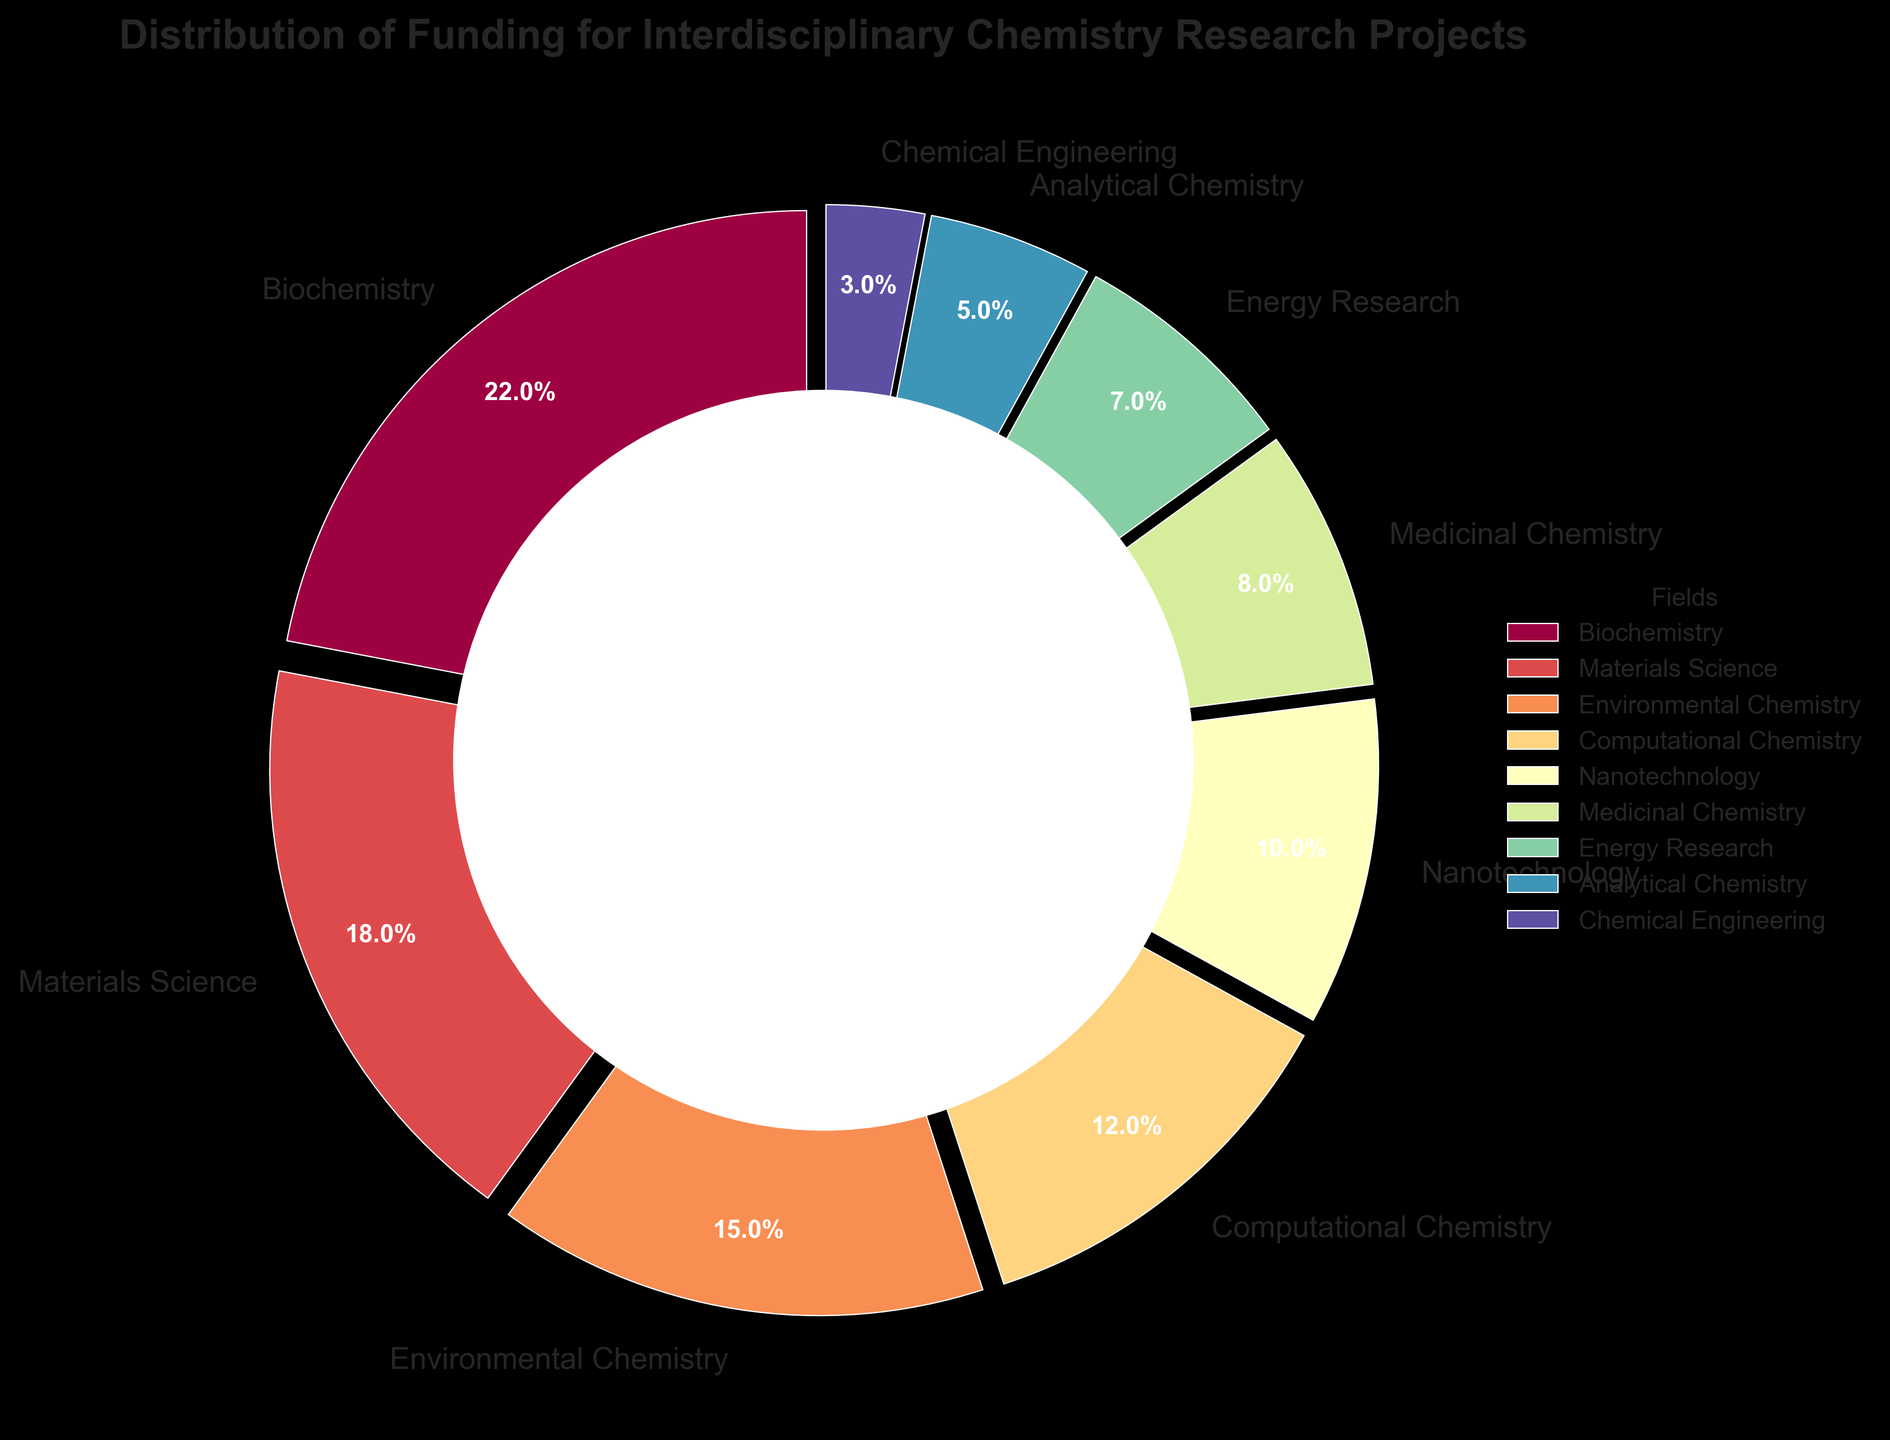What percentage of the total funding is allocated to Biochemistry and Materials Science combined? To find the combined percentage of funding for Biochemistry and Materials Science, add their individual percentages together. Biochemistry receives 22% and Materials Science receives 18%. So, 22% + 18% = 40%.
Answer: 40% Which field receives the least amount of funding? To identify the field with the least amount of funding, look for the smallest percentage in the pie chart. Chemical Engineering is allocated 3% of the funding, which is the smallest percentage among all the fields.
Answer: Chemical Engineering How much more funding does Computational Chemistry receive compared to Analytical Chemistry? To find how much more funding Computational Chemistry receives compared to Analytical Chemistry, subtract the percentage of funding for Analytical Chemistry from that for Computational Chemistry. Computational Chemistry has 12% funding, and Analytical Chemistry has 5%. So, 12% - 5% = 7%.
Answer: 7% Rank the fields in descending order of funding allocation. To rank the fields in descending order of funding allocation, list them from the highest percentage to the lowest percentage: Biochemistry (22%), Materials Science (18%), Environmental Chemistry (15%), Computational Chemistry (12%), Nanotechnology (10%), Medicinal Chemistry (8%), Energy Research (7%), Analytical Chemistry (5%), Chemical Engineering (3%).
Answer: Biochemistry, Materials Science, Environmental Chemistry, Computational Chemistry, Nanotechnology, Medicinal Chemistry, Energy Research, Analytical Chemistry, Chemical Engineering By what factor is the funding for Biochemistry greater than that for Energy Research? To find the factor by which Biochemistry's funding is greater than Energy Research's, divide the percentage of funding for Biochemistry by that for Energy Research. Biochemistry has 22% and Energy Research has 7%. So, 22 / 7 ≈ 3.14.
Answer: 3.14 Which three fields receive the highest funding and what are their corresponding percentages? To determine the three fields that receive the highest funding, look for the top three percentages in the pie chart. The fields with the highest funding are Biochemistry (22%), Materials Science (18%), and Environmental Chemistry (15%).
Answer: Biochemistry (22%), Materials Science (18%), Environmental Chemistry (15%) What is the average percentage of funding for the fields of Medicinal Chemistry, Energy Research, and Analytical Chemistry? To find the average percentage of funding for Medicinal Chemistry, Energy Research, and Analytical Chemistry, add their percentages together and divide by the number of fields. Medicinal Chemistry has 8%, Energy Research has 7%, and Analytical Chemistry has 5%. So, (8% + 7% + 5%) / 3 = 20% / 3 = 6.67%.
Answer: 6.67% Is the funding for Nanotechnology more or less than half of the total funding for Biochemistry and Materials Science combined? To determine this, compare the funding for Nanotechnology (10%) with half of the combined funding of Biochemistry and Materials Science, which is 40%. Half of 40% is 20%. Since 10% is less than 20%, the funding for Nanotechnology is less than half of the combined funding for Biochemistry and Materials Science.
Answer: Less Does the sum of funding for Environmental Chemistry and Nanotechnology exceed that of Materials Science? To evaluate this, add the funding percentages for Environmental Chemistry (15%) and Nanotechnology (10%). Their sum is 25%. Then compare this sum to the funding for Materials Science, which is 18%. Since 25% > 18%, the sum of funding for Environmental Chemistry and Nanotechnology exceeds that of Materials Science.
Answer: Yes 